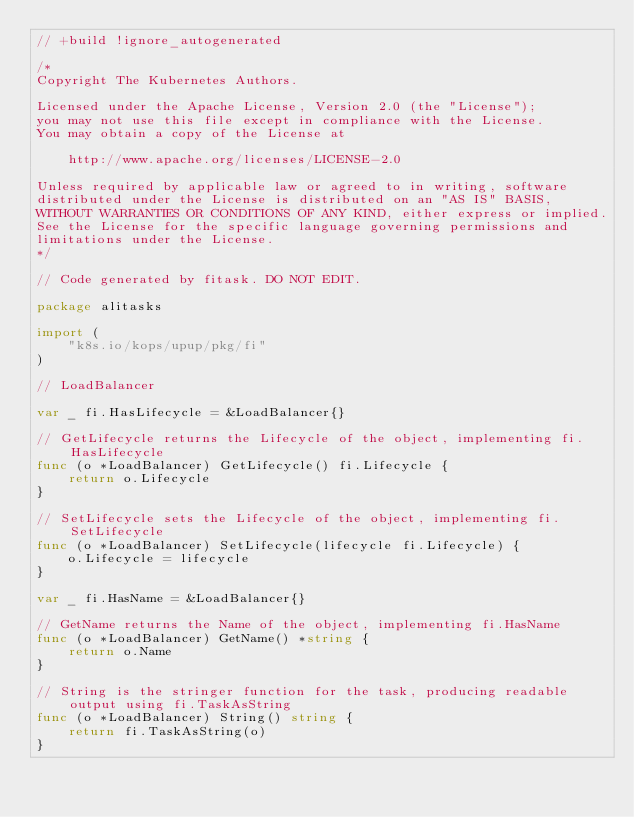<code> <loc_0><loc_0><loc_500><loc_500><_Go_>// +build !ignore_autogenerated

/*
Copyright The Kubernetes Authors.

Licensed under the Apache License, Version 2.0 (the "License");
you may not use this file except in compliance with the License.
You may obtain a copy of the License at

    http://www.apache.org/licenses/LICENSE-2.0

Unless required by applicable law or agreed to in writing, software
distributed under the License is distributed on an "AS IS" BASIS,
WITHOUT WARRANTIES OR CONDITIONS OF ANY KIND, either express or implied.
See the License for the specific language governing permissions and
limitations under the License.
*/

// Code generated by fitask. DO NOT EDIT.

package alitasks

import (
	"k8s.io/kops/upup/pkg/fi"
)

// LoadBalancer

var _ fi.HasLifecycle = &LoadBalancer{}

// GetLifecycle returns the Lifecycle of the object, implementing fi.HasLifecycle
func (o *LoadBalancer) GetLifecycle() fi.Lifecycle {
	return o.Lifecycle
}

// SetLifecycle sets the Lifecycle of the object, implementing fi.SetLifecycle
func (o *LoadBalancer) SetLifecycle(lifecycle fi.Lifecycle) {
	o.Lifecycle = lifecycle
}

var _ fi.HasName = &LoadBalancer{}

// GetName returns the Name of the object, implementing fi.HasName
func (o *LoadBalancer) GetName() *string {
	return o.Name
}

// String is the stringer function for the task, producing readable output using fi.TaskAsString
func (o *LoadBalancer) String() string {
	return fi.TaskAsString(o)
}
</code> 